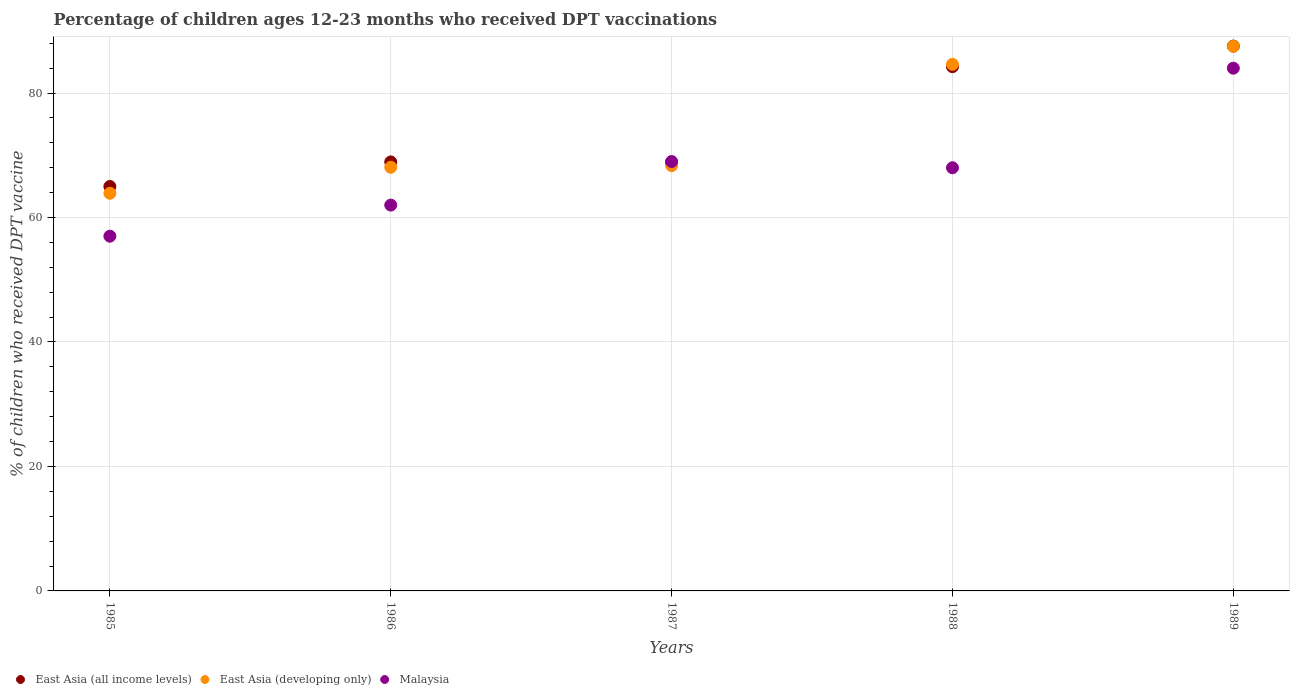Is the number of dotlines equal to the number of legend labels?
Provide a short and direct response. Yes. What is the percentage of children who received DPT vaccination in East Asia (developing only) in 1987?
Make the answer very short. 68.34. Across all years, what is the maximum percentage of children who received DPT vaccination in East Asia (developing only)?
Give a very brief answer. 87.52. Across all years, what is the minimum percentage of children who received DPT vaccination in East Asia (developing only)?
Provide a succinct answer. 63.9. In which year was the percentage of children who received DPT vaccination in East Asia (all income levels) minimum?
Your response must be concise. 1985. What is the total percentage of children who received DPT vaccination in East Asia (developing only) in the graph?
Give a very brief answer. 372.46. What is the difference between the percentage of children who received DPT vaccination in East Asia (developing only) in 1985 and that in 1986?
Make the answer very short. -4.18. What is the difference between the percentage of children who received DPT vaccination in East Asia (all income levels) in 1988 and the percentage of children who received DPT vaccination in Malaysia in 1986?
Make the answer very short. 22.24. In the year 1989, what is the difference between the percentage of children who received DPT vaccination in Malaysia and percentage of children who received DPT vaccination in East Asia (developing only)?
Make the answer very short. -3.52. In how many years, is the percentage of children who received DPT vaccination in East Asia (all income levels) greater than 8 %?
Offer a very short reply. 5. What is the ratio of the percentage of children who received DPT vaccination in East Asia (all income levels) in 1985 to that in 1987?
Provide a succinct answer. 0.94. Is the percentage of children who received DPT vaccination in Malaysia in 1985 less than that in 1986?
Offer a terse response. Yes. What is the difference between the highest and the second highest percentage of children who received DPT vaccination in Malaysia?
Your answer should be very brief. 15. What is the difference between the highest and the lowest percentage of children who received DPT vaccination in Malaysia?
Keep it short and to the point. 27. In how many years, is the percentage of children who received DPT vaccination in Malaysia greater than the average percentage of children who received DPT vaccination in Malaysia taken over all years?
Provide a succinct answer. 2. Is it the case that in every year, the sum of the percentage of children who received DPT vaccination in East Asia (all income levels) and percentage of children who received DPT vaccination in East Asia (developing only)  is greater than the percentage of children who received DPT vaccination in Malaysia?
Keep it short and to the point. Yes. Is the percentage of children who received DPT vaccination in East Asia (all income levels) strictly greater than the percentage of children who received DPT vaccination in Malaysia over the years?
Ensure brevity in your answer.  No. How many dotlines are there?
Your answer should be compact. 3. How many years are there in the graph?
Offer a very short reply. 5. Are the values on the major ticks of Y-axis written in scientific E-notation?
Offer a very short reply. No. Does the graph contain any zero values?
Keep it short and to the point. No. What is the title of the graph?
Offer a terse response. Percentage of children ages 12-23 months who received DPT vaccinations. Does "Rwanda" appear as one of the legend labels in the graph?
Give a very brief answer. No. What is the label or title of the Y-axis?
Provide a short and direct response. % of children who received DPT vaccine. What is the % of children who received DPT vaccine of East Asia (all income levels) in 1985?
Provide a short and direct response. 64.99. What is the % of children who received DPT vaccine of East Asia (developing only) in 1985?
Your answer should be compact. 63.9. What is the % of children who received DPT vaccine in Malaysia in 1985?
Offer a terse response. 57. What is the % of children who received DPT vaccine of East Asia (all income levels) in 1986?
Your response must be concise. 68.94. What is the % of children who received DPT vaccine in East Asia (developing only) in 1986?
Your answer should be very brief. 68.08. What is the % of children who received DPT vaccine in Malaysia in 1986?
Offer a very short reply. 62. What is the % of children who received DPT vaccine in East Asia (all income levels) in 1987?
Your response must be concise. 68.83. What is the % of children who received DPT vaccine in East Asia (developing only) in 1987?
Offer a very short reply. 68.34. What is the % of children who received DPT vaccine in East Asia (all income levels) in 1988?
Offer a terse response. 84.24. What is the % of children who received DPT vaccine in East Asia (developing only) in 1988?
Give a very brief answer. 84.62. What is the % of children who received DPT vaccine in Malaysia in 1988?
Offer a terse response. 68. What is the % of children who received DPT vaccine of East Asia (all income levels) in 1989?
Make the answer very short. 87.55. What is the % of children who received DPT vaccine in East Asia (developing only) in 1989?
Your response must be concise. 87.52. Across all years, what is the maximum % of children who received DPT vaccine in East Asia (all income levels)?
Offer a terse response. 87.55. Across all years, what is the maximum % of children who received DPT vaccine of East Asia (developing only)?
Your answer should be very brief. 87.52. Across all years, what is the minimum % of children who received DPT vaccine of East Asia (all income levels)?
Offer a terse response. 64.99. Across all years, what is the minimum % of children who received DPT vaccine of East Asia (developing only)?
Your answer should be very brief. 63.9. What is the total % of children who received DPT vaccine of East Asia (all income levels) in the graph?
Give a very brief answer. 374.56. What is the total % of children who received DPT vaccine of East Asia (developing only) in the graph?
Ensure brevity in your answer.  372.46. What is the total % of children who received DPT vaccine in Malaysia in the graph?
Ensure brevity in your answer.  340. What is the difference between the % of children who received DPT vaccine in East Asia (all income levels) in 1985 and that in 1986?
Your answer should be very brief. -3.95. What is the difference between the % of children who received DPT vaccine in East Asia (developing only) in 1985 and that in 1986?
Offer a very short reply. -4.18. What is the difference between the % of children who received DPT vaccine of Malaysia in 1985 and that in 1986?
Offer a terse response. -5. What is the difference between the % of children who received DPT vaccine in East Asia (all income levels) in 1985 and that in 1987?
Ensure brevity in your answer.  -3.85. What is the difference between the % of children who received DPT vaccine in East Asia (developing only) in 1985 and that in 1987?
Your answer should be very brief. -4.44. What is the difference between the % of children who received DPT vaccine of Malaysia in 1985 and that in 1987?
Provide a succinct answer. -12. What is the difference between the % of children who received DPT vaccine of East Asia (all income levels) in 1985 and that in 1988?
Give a very brief answer. -19.26. What is the difference between the % of children who received DPT vaccine of East Asia (developing only) in 1985 and that in 1988?
Ensure brevity in your answer.  -20.72. What is the difference between the % of children who received DPT vaccine of Malaysia in 1985 and that in 1988?
Ensure brevity in your answer.  -11. What is the difference between the % of children who received DPT vaccine in East Asia (all income levels) in 1985 and that in 1989?
Offer a very short reply. -22.56. What is the difference between the % of children who received DPT vaccine in East Asia (developing only) in 1985 and that in 1989?
Your response must be concise. -23.62. What is the difference between the % of children who received DPT vaccine of Malaysia in 1985 and that in 1989?
Your answer should be compact. -27. What is the difference between the % of children who received DPT vaccine of East Asia (all income levels) in 1986 and that in 1987?
Offer a terse response. 0.1. What is the difference between the % of children who received DPT vaccine in East Asia (developing only) in 1986 and that in 1987?
Keep it short and to the point. -0.26. What is the difference between the % of children who received DPT vaccine in East Asia (all income levels) in 1986 and that in 1988?
Provide a succinct answer. -15.31. What is the difference between the % of children who received DPT vaccine of East Asia (developing only) in 1986 and that in 1988?
Ensure brevity in your answer.  -16.54. What is the difference between the % of children who received DPT vaccine of Malaysia in 1986 and that in 1988?
Your answer should be compact. -6. What is the difference between the % of children who received DPT vaccine in East Asia (all income levels) in 1986 and that in 1989?
Your response must be concise. -18.61. What is the difference between the % of children who received DPT vaccine in East Asia (developing only) in 1986 and that in 1989?
Your answer should be compact. -19.44. What is the difference between the % of children who received DPT vaccine of East Asia (all income levels) in 1987 and that in 1988?
Make the answer very short. -15.41. What is the difference between the % of children who received DPT vaccine in East Asia (developing only) in 1987 and that in 1988?
Keep it short and to the point. -16.28. What is the difference between the % of children who received DPT vaccine in Malaysia in 1987 and that in 1988?
Provide a short and direct response. 1. What is the difference between the % of children who received DPT vaccine in East Asia (all income levels) in 1987 and that in 1989?
Make the answer very short. -18.72. What is the difference between the % of children who received DPT vaccine of East Asia (developing only) in 1987 and that in 1989?
Give a very brief answer. -19.18. What is the difference between the % of children who received DPT vaccine of Malaysia in 1987 and that in 1989?
Ensure brevity in your answer.  -15. What is the difference between the % of children who received DPT vaccine in East Asia (all income levels) in 1988 and that in 1989?
Keep it short and to the point. -3.31. What is the difference between the % of children who received DPT vaccine of East Asia (developing only) in 1988 and that in 1989?
Provide a short and direct response. -2.9. What is the difference between the % of children who received DPT vaccine of East Asia (all income levels) in 1985 and the % of children who received DPT vaccine of East Asia (developing only) in 1986?
Provide a short and direct response. -3.09. What is the difference between the % of children who received DPT vaccine of East Asia (all income levels) in 1985 and the % of children who received DPT vaccine of Malaysia in 1986?
Offer a terse response. 2.99. What is the difference between the % of children who received DPT vaccine in East Asia (developing only) in 1985 and the % of children who received DPT vaccine in Malaysia in 1986?
Offer a very short reply. 1.9. What is the difference between the % of children who received DPT vaccine of East Asia (all income levels) in 1985 and the % of children who received DPT vaccine of East Asia (developing only) in 1987?
Your answer should be compact. -3.35. What is the difference between the % of children who received DPT vaccine of East Asia (all income levels) in 1985 and the % of children who received DPT vaccine of Malaysia in 1987?
Your response must be concise. -4.01. What is the difference between the % of children who received DPT vaccine of East Asia (developing only) in 1985 and the % of children who received DPT vaccine of Malaysia in 1987?
Your answer should be compact. -5.1. What is the difference between the % of children who received DPT vaccine of East Asia (all income levels) in 1985 and the % of children who received DPT vaccine of East Asia (developing only) in 1988?
Offer a very short reply. -19.63. What is the difference between the % of children who received DPT vaccine in East Asia (all income levels) in 1985 and the % of children who received DPT vaccine in Malaysia in 1988?
Provide a succinct answer. -3.01. What is the difference between the % of children who received DPT vaccine of East Asia (developing only) in 1985 and the % of children who received DPT vaccine of Malaysia in 1988?
Offer a very short reply. -4.1. What is the difference between the % of children who received DPT vaccine in East Asia (all income levels) in 1985 and the % of children who received DPT vaccine in East Asia (developing only) in 1989?
Your answer should be very brief. -22.53. What is the difference between the % of children who received DPT vaccine of East Asia (all income levels) in 1985 and the % of children who received DPT vaccine of Malaysia in 1989?
Offer a terse response. -19.01. What is the difference between the % of children who received DPT vaccine of East Asia (developing only) in 1985 and the % of children who received DPT vaccine of Malaysia in 1989?
Your answer should be very brief. -20.1. What is the difference between the % of children who received DPT vaccine in East Asia (all income levels) in 1986 and the % of children who received DPT vaccine in East Asia (developing only) in 1987?
Ensure brevity in your answer.  0.6. What is the difference between the % of children who received DPT vaccine in East Asia (all income levels) in 1986 and the % of children who received DPT vaccine in Malaysia in 1987?
Provide a succinct answer. -0.06. What is the difference between the % of children who received DPT vaccine in East Asia (developing only) in 1986 and the % of children who received DPT vaccine in Malaysia in 1987?
Your response must be concise. -0.92. What is the difference between the % of children who received DPT vaccine of East Asia (all income levels) in 1986 and the % of children who received DPT vaccine of East Asia (developing only) in 1988?
Ensure brevity in your answer.  -15.68. What is the difference between the % of children who received DPT vaccine in East Asia (all income levels) in 1986 and the % of children who received DPT vaccine in Malaysia in 1988?
Provide a short and direct response. 0.94. What is the difference between the % of children who received DPT vaccine of East Asia (developing only) in 1986 and the % of children who received DPT vaccine of Malaysia in 1988?
Provide a short and direct response. 0.08. What is the difference between the % of children who received DPT vaccine in East Asia (all income levels) in 1986 and the % of children who received DPT vaccine in East Asia (developing only) in 1989?
Make the answer very short. -18.58. What is the difference between the % of children who received DPT vaccine in East Asia (all income levels) in 1986 and the % of children who received DPT vaccine in Malaysia in 1989?
Provide a succinct answer. -15.06. What is the difference between the % of children who received DPT vaccine of East Asia (developing only) in 1986 and the % of children who received DPT vaccine of Malaysia in 1989?
Provide a short and direct response. -15.92. What is the difference between the % of children who received DPT vaccine of East Asia (all income levels) in 1987 and the % of children who received DPT vaccine of East Asia (developing only) in 1988?
Give a very brief answer. -15.79. What is the difference between the % of children who received DPT vaccine of East Asia (all income levels) in 1987 and the % of children who received DPT vaccine of Malaysia in 1988?
Offer a terse response. 0.83. What is the difference between the % of children who received DPT vaccine of East Asia (developing only) in 1987 and the % of children who received DPT vaccine of Malaysia in 1988?
Your response must be concise. 0.34. What is the difference between the % of children who received DPT vaccine of East Asia (all income levels) in 1987 and the % of children who received DPT vaccine of East Asia (developing only) in 1989?
Your response must be concise. -18.69. What is the difference between the % of children who received DPT vaccine of East Asia (all income levels) in 1987 and the % of children who received DPT vaccine of Malaysia in 1989?
Your response must be concise. -15.17. What is the difference between the % of children who received DPT vaccine in East Asia (developing only) in 1987 and the % of children who received DPT vaccine in Malaysia in 1989?
Your response must be concise. -15.66. What is the difference between the % of children who received DPT vaccine of East Asia (all income levels) in 1988 and the % of children who received DPT vaccine of East Asia (developing only) in 1989?
Give a very brief answer. -3.28. What is the difference between the % of children who received DPT vaccine in East Asia (all income levels) in 1988 and the % of children who received DPT vaccine in Malaysia in 1989?
Your answer should be very brief. 0.24. What is the difference between the % of children who received DPT vaccine of East Asia (developing only) in 1988 and the % of children who received DPT vaccine of Malaysia in 1989?
Offer a very short reply. 0.62. What is the average % of children who received DPT vaccine in East Asia (all income levels) per year?
Provide a short and direct response. 74.91. What is the average % of children who received DPT vaccine of East Asia (developing only) per year?
Offer a very short reply. 74.49. In the year 1985, what is the difference between the % of children who received DPT vaccine in East Asia (all income levels) and % of children who received DPT vaccine in East Asia (developing only)?
Your answer should be very brief. 1.09. In the year 1985, what is the difference between the % of children who received DPT vaccine in East Asia (all income levels) and % of children who received DPT vaccine in Malaysia?
Provide a short and direct response. 7.99. In the year 1985, what is the difference between the % of children who received DPT vaccine in East Asia (developing only) and % of children who received DPT vaccine in Malaysia?
Your answer should be compact. 6.9. In the year 1986, what is the difference between the % of children who received DPT vaccine of East Asia (all income levels) and % of children who received DPT vaccine of East Asia (developing only)?
Provide a succinct answer. 0.86. In the year 1986, what is the difference between the % of children who received DPT vaccine of East Asia (all income levels) and % of children who received DPT vaccine of Malaysia?
Provide a short and direct response. 6.94. In the year 1986, what is the difference between the % of children who received DPT vaccine in East Asia (developing only) and % of children who received DPT vaccine in Malaysia?
Provide a succinct answer. 6.08. In the year 1987, what is the difference between the % of children who received DPT vaccine of East Asia (all income levels) and % of children who received DPT vaccine of East Asia (developing only)?
Your answer should be very brief. 0.5. In the year 1987, what is the difference between the % of children who received DPT vaccine in East Asia (all income levels) and % of children who received DPT vaccine in Malaysia?
Provide a succinct answer. -0.17. In the year 1987, what is the difference between the % of children who received DPT vaccine in East Asia (developing only) and % of children who received DPT vaccine in Malaysia?
Ensure brevity in your answer.  -0.66. In the year 1988, what is the difference between the % of children who received DPT vaccine of East Asia (all income levels) and % of children who received DPT vaccine of East Asia (developing only)?
Your response must be concise. -0.38. In the year 1988, what is the difference between the % of children who received DPT vaccine in East Asia (all income levels) and % of children who received DPT vaccine in Malaysia?
Provide a succinct answer. 16.24. In the year 1988, what is the difference between the % of children who received DPT vaccine in East Asia (developing only) and % of children who received DPT vaccine in Malaysia?
Make the answer very short. 16.62. In the year 1989, what is the difference between the % of children who received DPT vaccine of East Asia (all income levels) and % of children who received DPT vaccine of East Asia (developing only)?
Ensure brevity in your answer.  0.03. In the year 1989, what is the difference between the % of children who received DPT vaccine of East Asia (all income levels) and % of children who received DPT vaccine of Malaysia?
Ensure brevity in your answer.  3.55. In the year 1989, what is the difference between the % of children who received DPT vaccine in East Asia (developing only) and % of children who received DPT vaccine in Malaysia?
Provide a short and direct response. 3.52. What is the ratio of the % of children who received DPT vaccine in East Asia (all income levels) in 1985 to that in 1986?
Provide a short and direct response. 0.94. What is the ratio of the % of children who received DPT vaccine in East Asia (developing only) in 1985 to that in 1986?
Provide a succinct answer. 0.94. What is the ratio of the % of children who received DPT vaccine of Malaysia in 1985 to that in 1986?
Ensure brevity in your answer.  0.92. What is the ratio of the % of children who received DPT vaccine in East Asia (all income levels) in 1985 to that in 1987?
Your answer should be compact. 0.94. What is the ratio of the % of children who received DPT vaccine of East Asia (developing only) in 1985 to that in 1987?
Offer a terse response. 0.94. What is the ratio of the % of children who received DPT vaccine in Malaysia in 1985 to that in 1987?
Offer a terse response. 0.83. What is the ratio of the % of children who received DPT vaccine of East Asia (all income levels) in 1985 to that in 1988?
Provide a short and direct response. 0.77. What is the ratio of the % of children who received DPT vaccine in East Asia (developing only) in 1985 to that in 1988?
Your answer should be compact. 0.76. What is the ratio of the % of children who received DPT vaccine in Malaysia in 1985 to that in 1988?
Provide a short and direct response. 0.84. What is the ratio of the % of children who received DPT vaccine in East Asia (all income levels) in 1985 to that in 1989?
Ensure brevity in your answer.  0.74. What is the ratio of the % of children who received DPT vaccine of East Asia (developing only) in 1985 to that in 1989?
Offer a very short reply. 0.73. What is the ratio of the % of children who received DPT vaccine of Malaysia in 1985 to that in 1989?
Give a very brief answer. 0.68. What is the ratio of the % of children who received DPT vaccine in Malaysia in 1986 to that in 1987?
Provide a short and direct response. 0.9. What is the ratio of the % of children who received DPT vaccine of East Asia (all income levels) in 1986 to that in 1988?
Your answer should be very brief. 0.82. What is the ratio of the % of children who received DPT vaccine in East Asia (developing only) in 1986 to that in 1988?
Your answer should be very brief. 0.8. What is the ratio of the % of children who received DPT vaccine in Malaysia in 1986 to that in 1988?
Provide a succinct answer. 0.91. What is the ratio of the % of children who received DPT vaccine in East Asia (all income levels) in 1986 to that in 1989?
Provide a short and direct response. 0.79. What is the ratio of the % of children who received DPT vaccine in East Asia (developing only) in 1986 to that in 1989?
Offer a very short reply. 0.78. What is the ratio of the % of children who received DPT vaccine of Malaysia in 1986 to that in 1989?
Make the answer very short. 0.74. What is the ratio of the % of children who received DPT vaccine of East Asia (all income levels) in 1987 to that in 1988?
Offer a very short reply. 0.82. What is the ratio of the % of children who received DPT vaccine in East Asia (developing only) in 1987 to that in 1988?
Make the answer very short. 0.81. What is the ratio of the % of children who received DPT vaccine of Malaysia in 1987 to that in 1988?
Your response must be concise. 1.01. What is the ratio of the % of children who received DPT vaccine in East Asia (all income levels) in 1987 to that in 1989?
Offer a terse response. 0.79. What is the ratio of the % of children who received DPT vaccine in East Asia (developing only) in 1987 to that in 1989?
Make the answer very short. 0.78. What is the ratio of the % of children who received DPT vaccine in Malaysia in 1987 to that in 1989?
Give a very brief answer. 0.82. What is the ratio of the % of children who received DPT vaccine of East Asia (all income levels) in 1988 to that in 1989?
Provide a succinct answer. 0.96. What is the ratio of the % of children who received DPT vaccine of East Asia (developing only) in 1988 to that in 1989?
Make the answer very short. 0.97. What is the ratio of the % of children who received DPT vaccine in Malaysia in 1988 to that in 1989?
Your answer should be compact. 0.81. What is the difference between the highest and the second highest % of children who received DPT vaccine in East Asia (all income levels)?
Provide a succinct answer. 3.31. What is the difference between the highest and the second highest % of children who received DPT vaccine of East Asia (developing only)?
Give a very brief answer. 2.9. What is the difference between the highest and the lowest % of children who received DPT vaccine of East Asia (all income levels)?
Make the answer very short. 22.56. What is the difference between the highest and the lowest % of children who received DPT vaccine in East Asia (developing only)?
Give a very brief answer. 23.62. What is the difference between the highest and the lowest % of children who received DPT vaccine of Malaysia?
Make the answer very short. 27. 